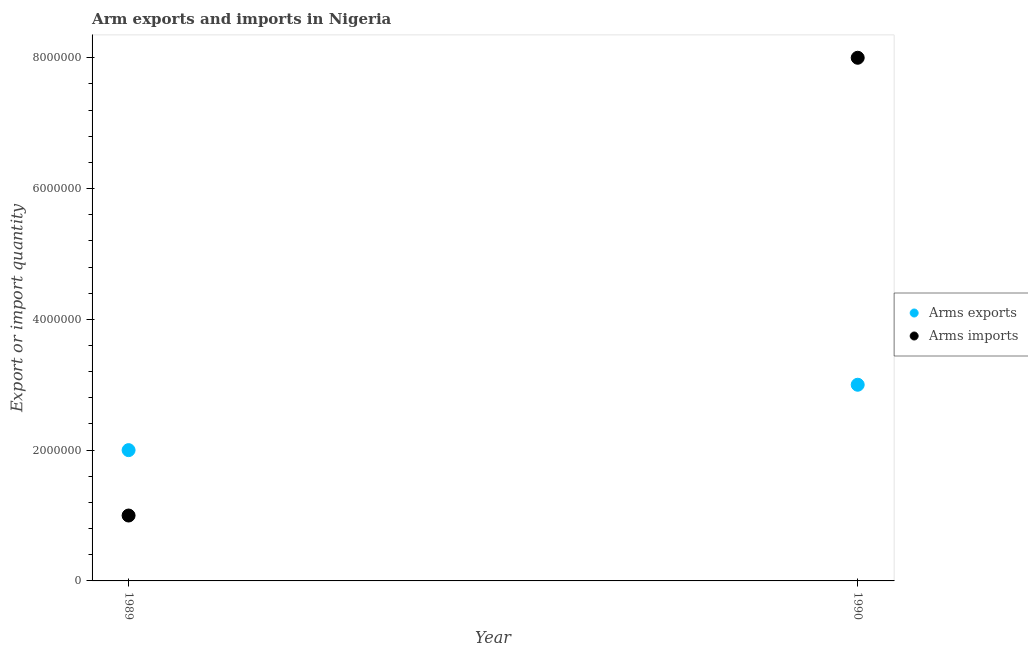How many different coloured dotlines are there?
Your answer should be very brief. 2. Is the number of dotlines equal to the number of legend labels?
Provide a short and direct response. Yes. What is the arms imports in 1990?
Provide a short and direct response. 8.00e+06. Across all years, what is the maximum arms imports?
Give a very brief answer. 8.00e+06. Across all years, what is the minimum arms imports?
Make the answer very short. 1.00e+06. In which year was the arms imports minimum?
Keep it short and to the point. 1989. What is the total arms imports in the graph?
Ensure brevity in your answer.  9.00e+06. What is the difference between the arms imports in 1989 and that in 1990?
Your answer should be very brief. -7.00e+06. What is the difference between the arms imports in 1989 and the arms exports in 1990?
Your response must be concise. -2.00e+06. What is the average arms imports per year?
Offer a terse response. 4.50e+06. In the year 1990, what is the difference between the arms exports and arms imports?
Your answer should be compact. -5.00e+06. In how many years, is the arms exports greater than 4400000?
Keep it short and to the point. 0. What is the ratio of the arms exports in 1989 to that in 1990?
Offer a terse response. 0.67. In how many years, is the arms imports greater than the average arms imports taken over all years?
Provide a short and direct response. 1. Is the arms imports strictly greater than the arms exports over the years?
Your answer should be compact. No. How many dotlines are there?
Offer a very short reply. 2. How many years are there in the graph?
Give a very brief answer. 2. Are the values on the major ticks of Y-axis written in scientific E-notation?
Ensure brevity in your answer.  No. How are the legend labels stacked?
Your answer should be very brief. Vertical. What is the title of the graph?
Make the answer very short. Arm exports and imports in Nigeria. What is the label or title of the X-axis?
Your answer should be very brief. Year. What is the label or title of the Y-axis?
Ensure brevity in your answer.  Export or import quantity. What is the Export or import quantity in Arms imports in 1989?
Your answer should be compact. 1.00e+06. What is the Export or import quantity of Arms exports in 1990?
Offer a terse response. 3.00e+06. Across all years, what is the minimum Export or import quantity in Arms imports?
Give a very brief answer. 1.00e+06. What is the total Export or import quantity of Arms exports in the graph?
Your response must be concise. 5.00e+06. What is the total Export or import quantity of Arms imports in the graph?
Give a very brief answer. 9.00e+06. What is the difference between the Export or import quantity of Arms exports in 1989 and that in 1990?
Give a very brief answer. -1.00e+06. What is the difference between the Export or import quantity in Arms imports in 1989 and that in 1990?
Give a very brief answer. -7.00e+06. What is the difference between the Export or import quantity in Arms exports in 1989 and the Export or import quantity in Arms imports in 1990?
Offer a terse response. -6.00e+06. What is the average Export or import quantity of Arms exports per year?
Keep it short and to the point. 2.50e+06. What is the average Export or import quantity of Arms imports per year?
Give a very brief answer. 4.50e+06. In the year 1990, what is the difference between the Export or import quantity in Arms exports and Export or import quantity in Arms imports?
Ensure brevity in your answer.  -5.00e+06. What is the difference between the highest and the second highest Export or import quantity of Arms exports?
Provide a short and direct response. 1.00e+06. What is the difference between the highest and the second highest Export or import quantity in Arms imports?
Your answer should be compact. 7.00e+06. 